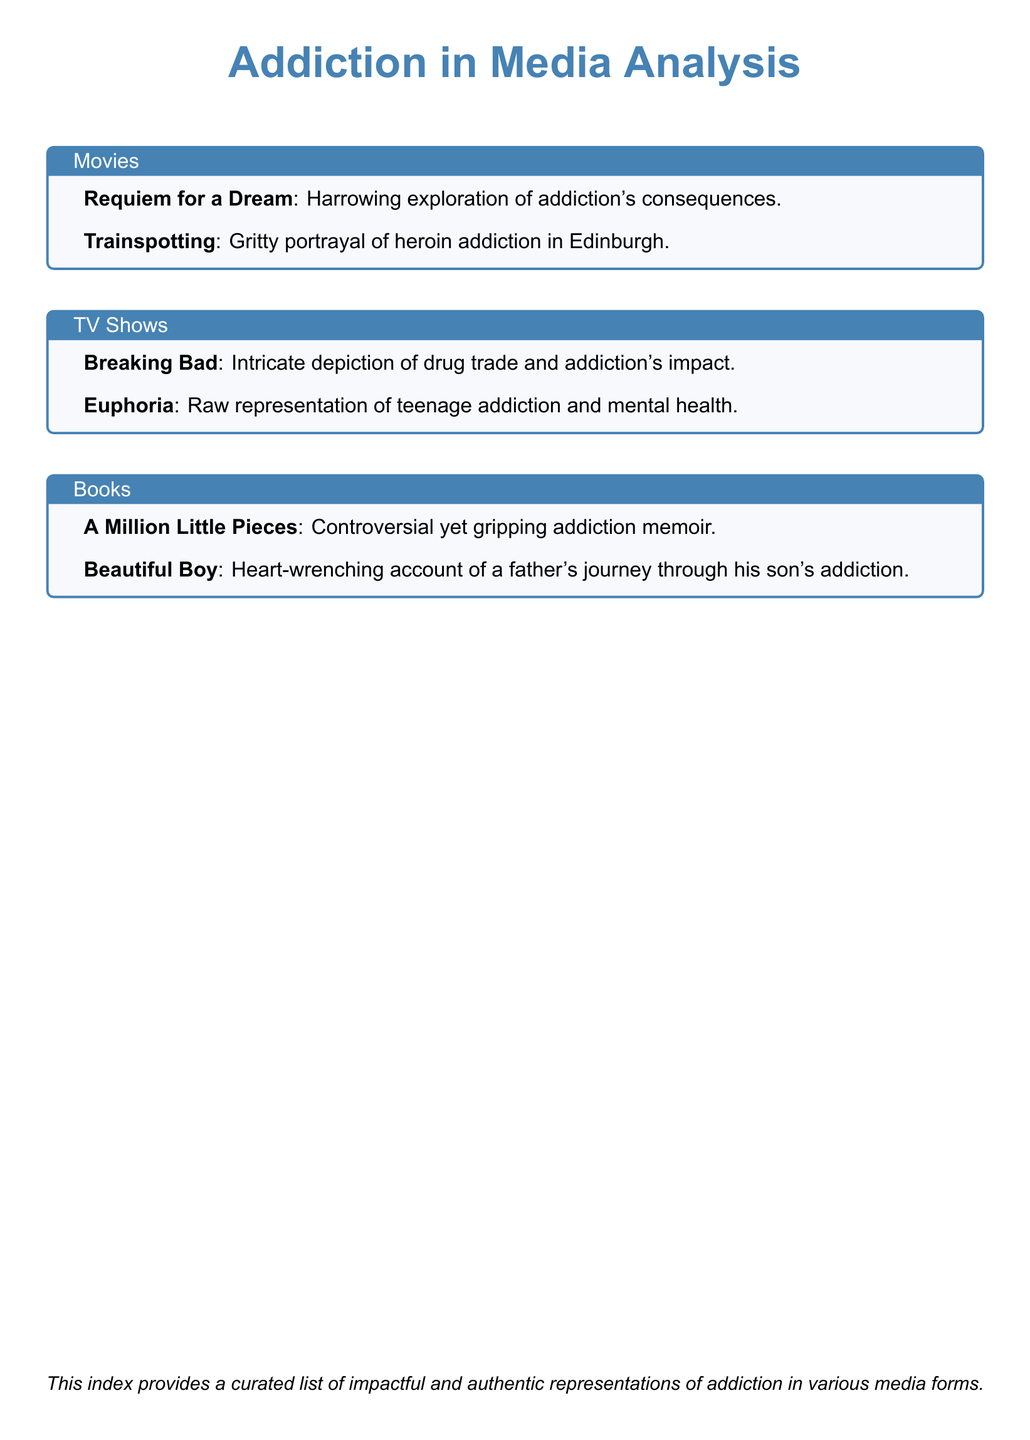What is the title of the movie that explores the consequences of addiction? The title of the movie is specifically mentioned as a harrowing exploration of addiction's consequences.
Answer: Requiem for a Dream Which TV show depicts teenage addiction? The TV show is highlighted as a raw representation of teenage addiction and mental health.
Answer: Euphoria What book offers a father's account of his son's addiction? The book is described as a heart-wrenching account of a father's journey through his son's addiction.
Answer: Beautiful Boy How many movies are listed in the document? The document provides a curated list which includes detailed two movies.
Answer: 2 Name one of the characters in "Trainspotting." The document specifically includes the title of the movie but does not list characters, therefore the answer cannot be derived directly.
Answer: N/A Which media type includes "A Million Little Pieces"? The book is explicitly categorized in the document under the book section emphasizing its controversial nature.
Answer: Books What is the tone of "Breaking Bad"? The show is characterized as an intricate depiction, requiring reasoning about its complexity in storytelling.
Answer: Intricate List one key theme portrayed in "Trainspotting." The document states that it is a gritty portrayal, thus referencing its theme without elaborating in precise detail.
Answer: Heroin addiction 